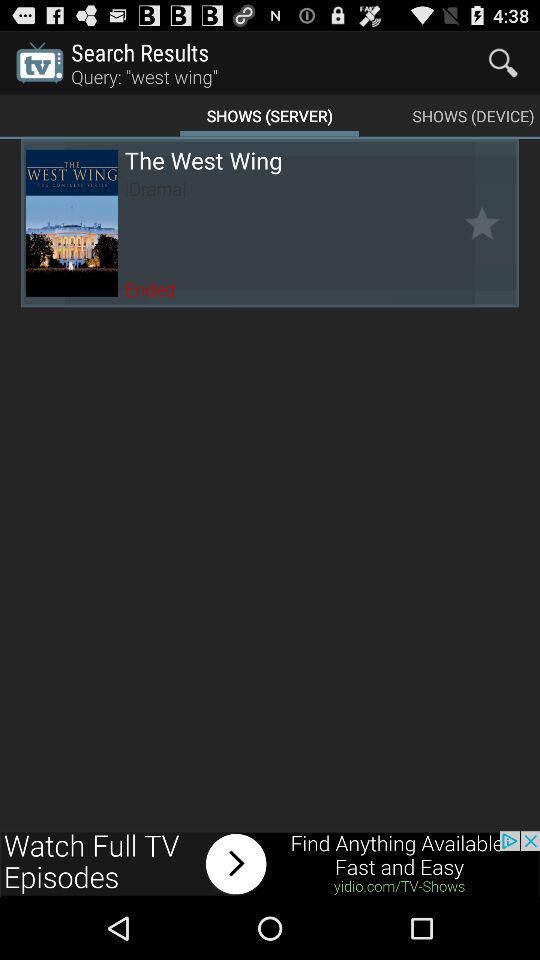Which tab is selected? The selected tab is "SHOWS (SERVER)". 